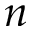<formula> <loc_0><loc_0><loc_500><loc_500>n</formula> 